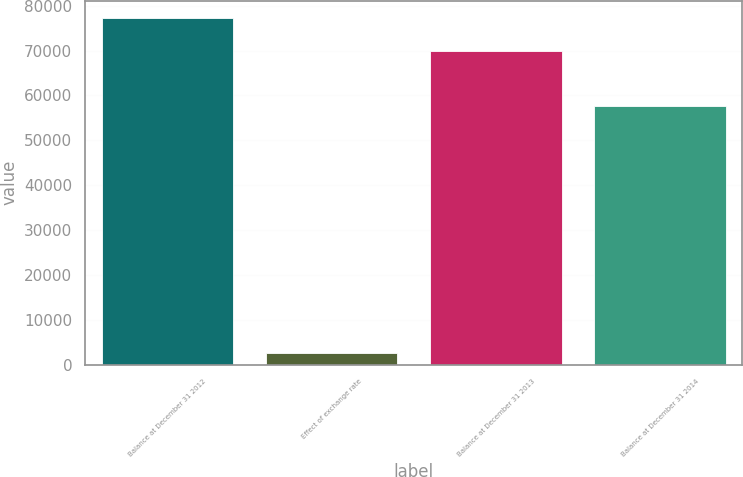Convert chart. <chart><loc_0><loc_0><loc_500><loc_500><bar_chart><fcel>Balance at December 31 2012<fcel>Effect of exchange rate<fcel>Balance at December 31 2013<fcel>Balance at December 31 2014<nl><fcel>77286.5<fcel>2468<fcel>70019<fcel>57698<nl></chart> 